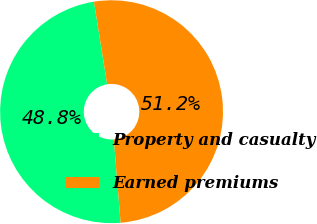<chart> <loc_0><loc_0><loc_500><loc_500><pie_chart><fcel>Property and casualty<fcel>Earned premiums<nl><fcel>48.77%<fcel>51.23%<nl></chart> 